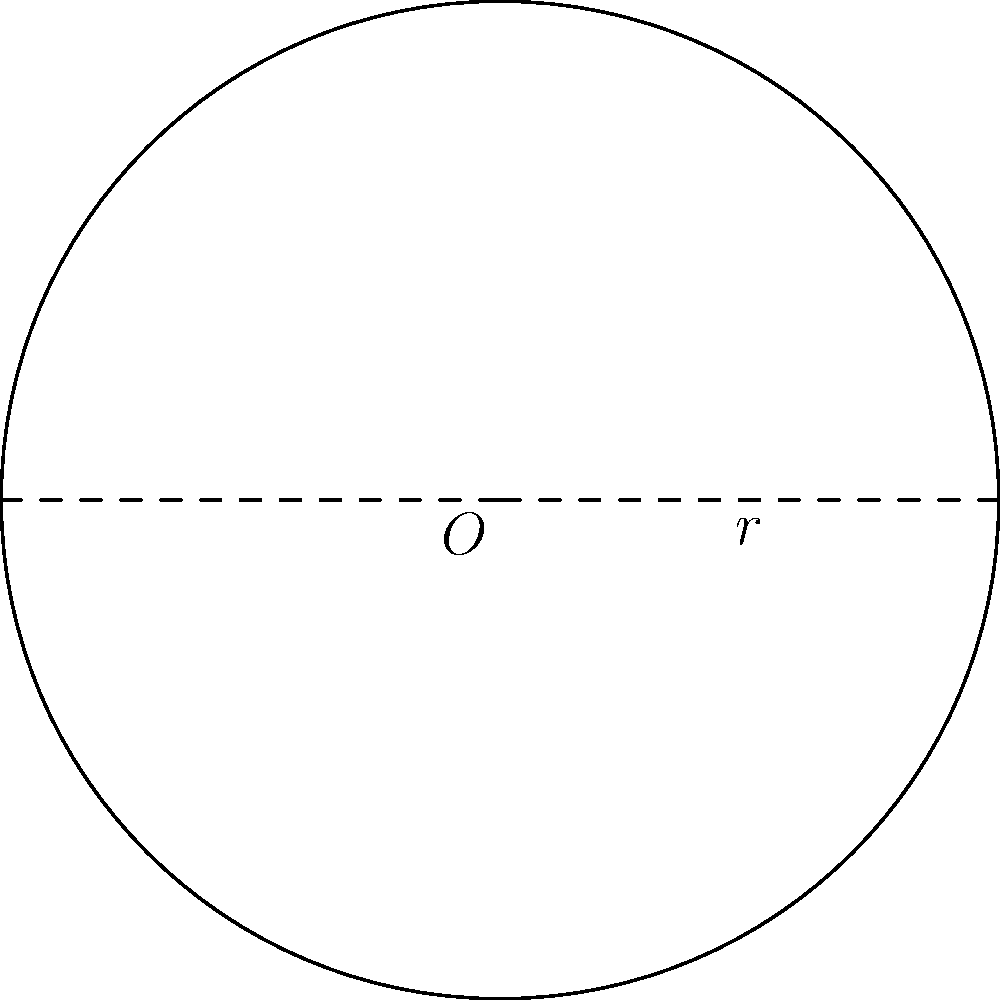As a community organizer, you're planning an outdoor event with a circular gathering space. The trauma surgeon you've invited to speak suggests that each attendee should have at least 4 square meters of space for comfort and social distancing. If the circular area has a radius of 10 meters, what is the maximum number of attendees that can be accommodated while meeting this requirement? Let's approach this step-by-step:

1) First, we need to calculate the total area of the circular gathering space.
   The formula for the area of a circle is $A = \pi r^2$

2) Given: radius $r = 10$ meters
   Area $A = \pi (10)^2 = 100\pi$ square meters

3) Now, we know that each attendee needs at least 4 square meters of space.
   Let's call the number of attendees $n$.

4) The inequality for this situation would be:
   $\frac{100\pi}{n} \geq 4$

5) Solving for $n$:
   $n \leq \frac{100\pi}{4} = 25\pi$

6) Since $n$ must be a whole number, we need to round down to the nearest integer.
   $25\pi \approx 78.54$

7) Therefore, the maximum number of attendees is 78.
Answer: 78 attendees 